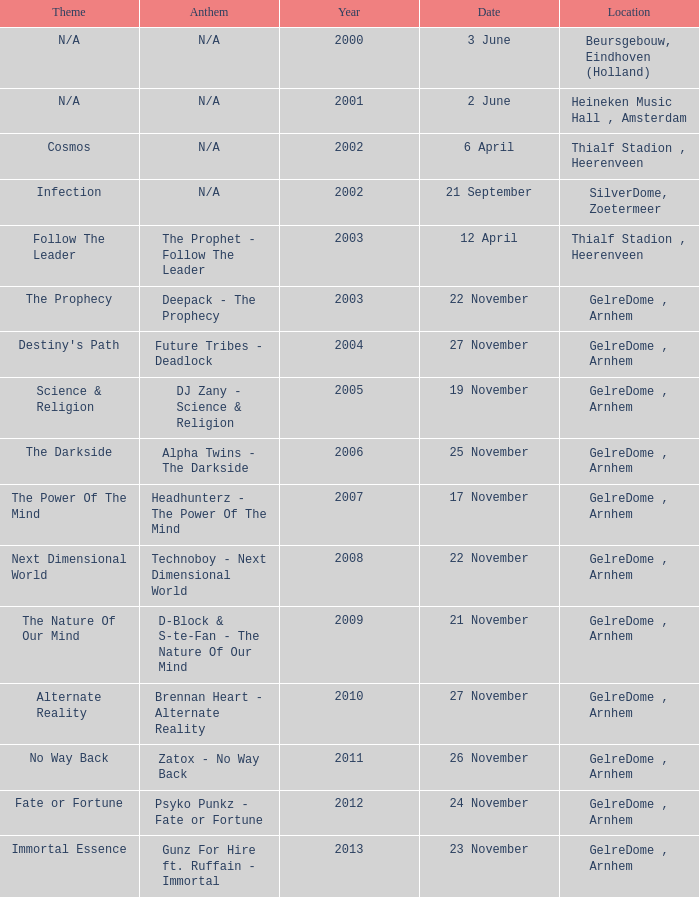What is the location in 2007? GelreDome , Arnhem. 